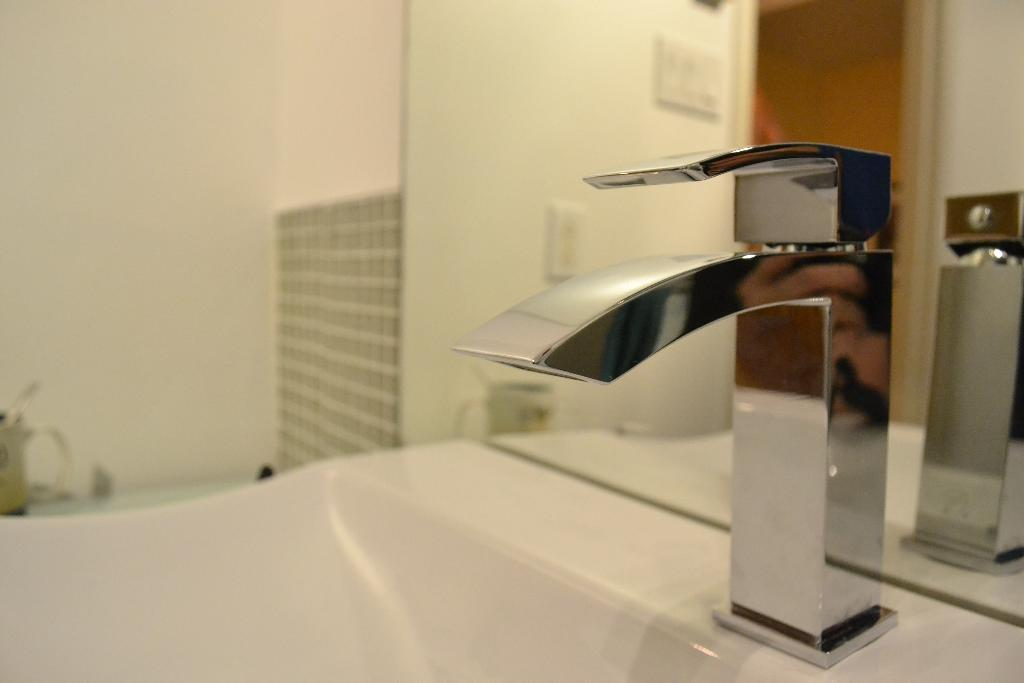What can be found in the image that is used for washing hands? There is a wash basin with a tap in the image. What is used for personal grooming in the image? There is a mirror in the image. What is the purpose of the cup in the image? The purpose of the cup in the image is not specified, but it could be used for holding water, toothbrushes, or other items. How many pipes are visible in the image? There are no pipes visible in the image. What is the amount of water in the cup in the image? The amount of water in the cup cannot be determined from the image, as the cup's contents are not visible. 